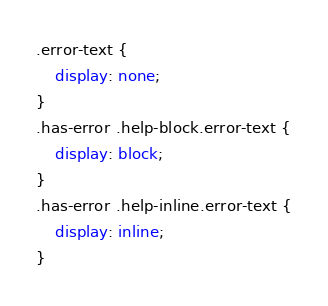<code> <loc_0><loc_0><loc_500><loc_500><_CSS_>.error-text {
    display: none;
}
.has-error .help-block.error-text {
    display: block;
}
.has-error .help-inline.error-text {
    display: inline;
}

</code> 